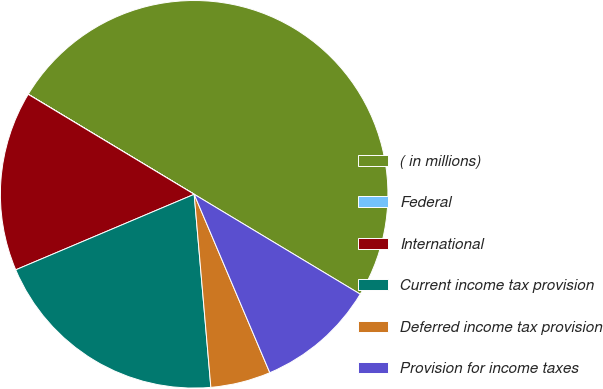Convert chart. <chart><loc_0><loc_0><loc_500><loc_500><pie_chart><fcel>( in millions)<fcel>Federal<fcel>International<fcel>Current income tax provision<fcel>Deferred income tax provision<fcel>Provision for income taxes<nl><fcel>49.98%<fcel>0.01%<fcel>15.0%<fcel>20.0%<fcel>5.01%<fcel>10.0%<nl></chart> 